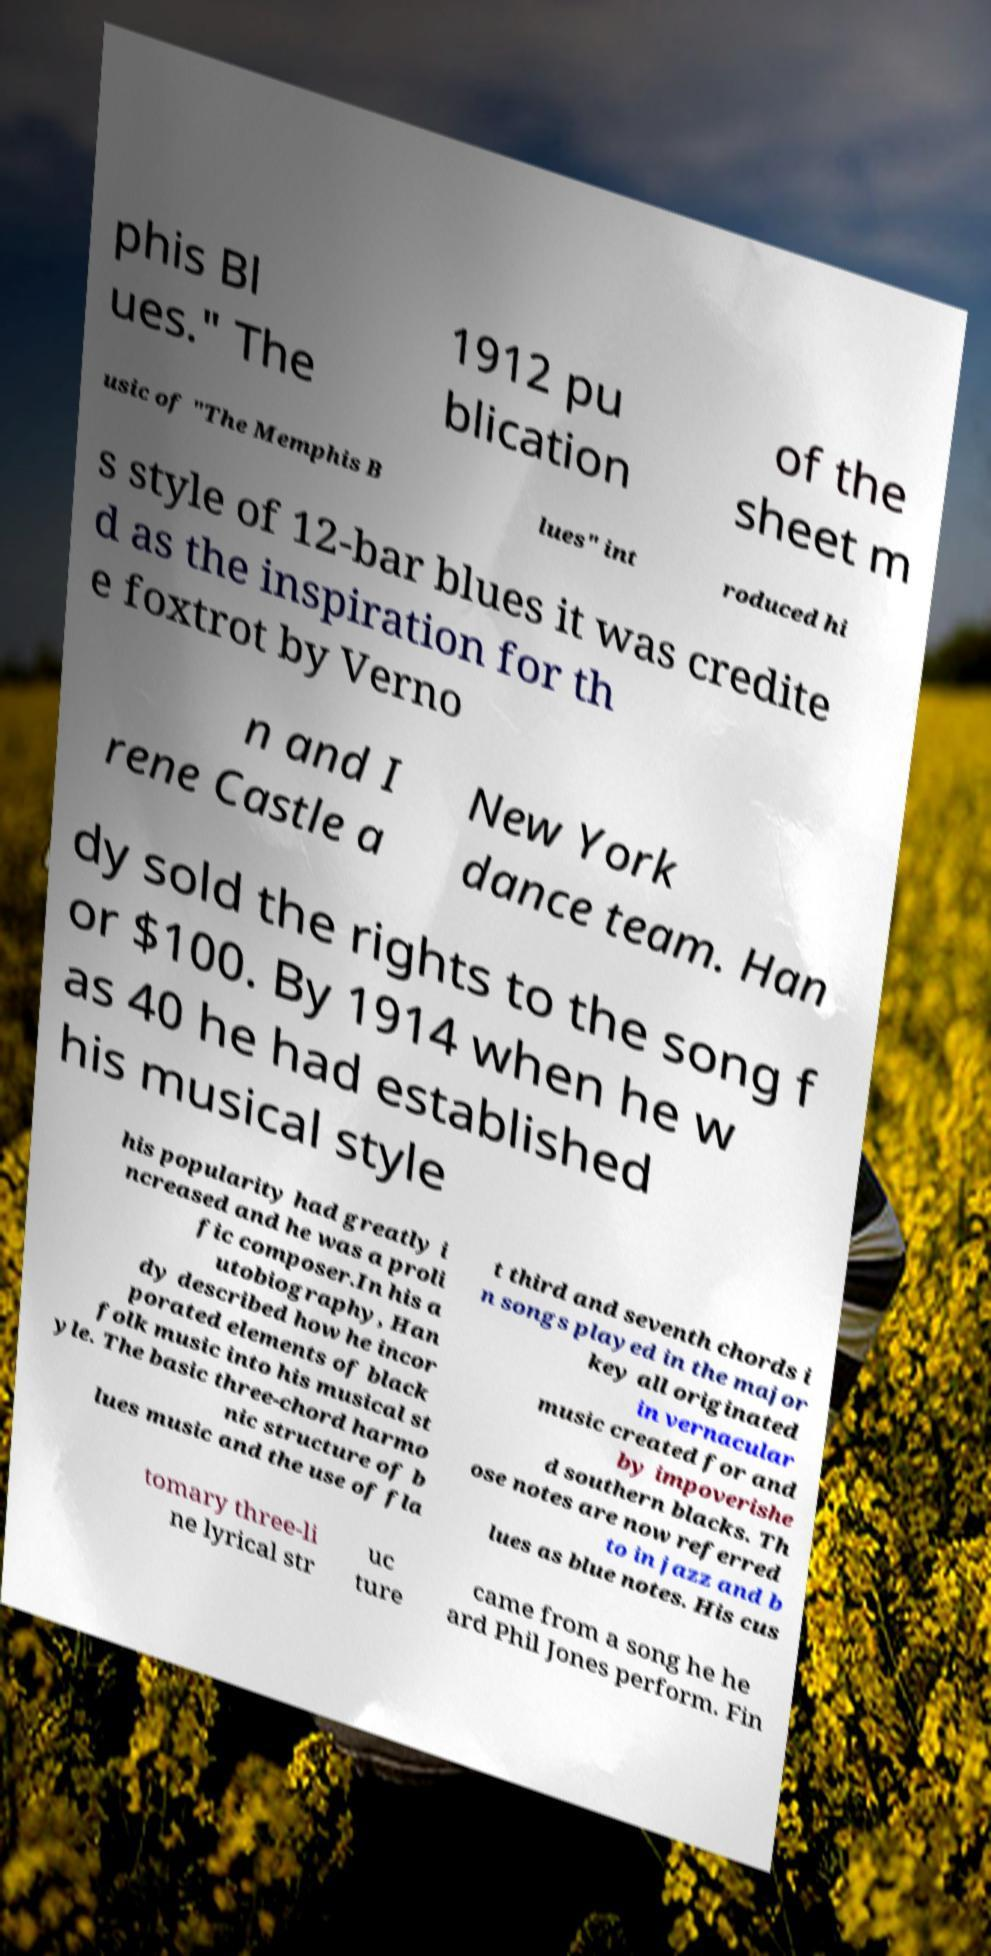Could you extract and type out the text from this image? phis Bl ues." The 1912 pu blication of the sheet m usic of "The Memphis B lues" int roduced hi s style of 12-bar blues it was credite d as the inspiration for th e foxtrot by Verno n and I rene Castle a New York dance team. Han dy sold the rights to the song f or $100. By 1914 when he w as 40 he had established his musical style his popularity had greatly i ncreased and he was a proli fic composer.In his a utobiography, Han dy described how he incor porated elements of black folk music into his musical st yle. The basic three-chord harmo nic structure of b lues music and the use of fla t third and seventh chords i n songs played in the major key all originated in vernacular music created for and by impoverishe d southern blacks. Th ose notes are now referred to in jazz and b lues as blue notes. His cus tomary three-li ne lyrical str uc ture came from a song he he ard Phil Jones perform. Fin 